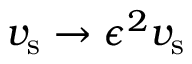<formula> <loc_0><loc_0><loc_500><loc_500>v _ { s } \rightarrow \epsilon ^ { 2 } v _ { s }</formula> 